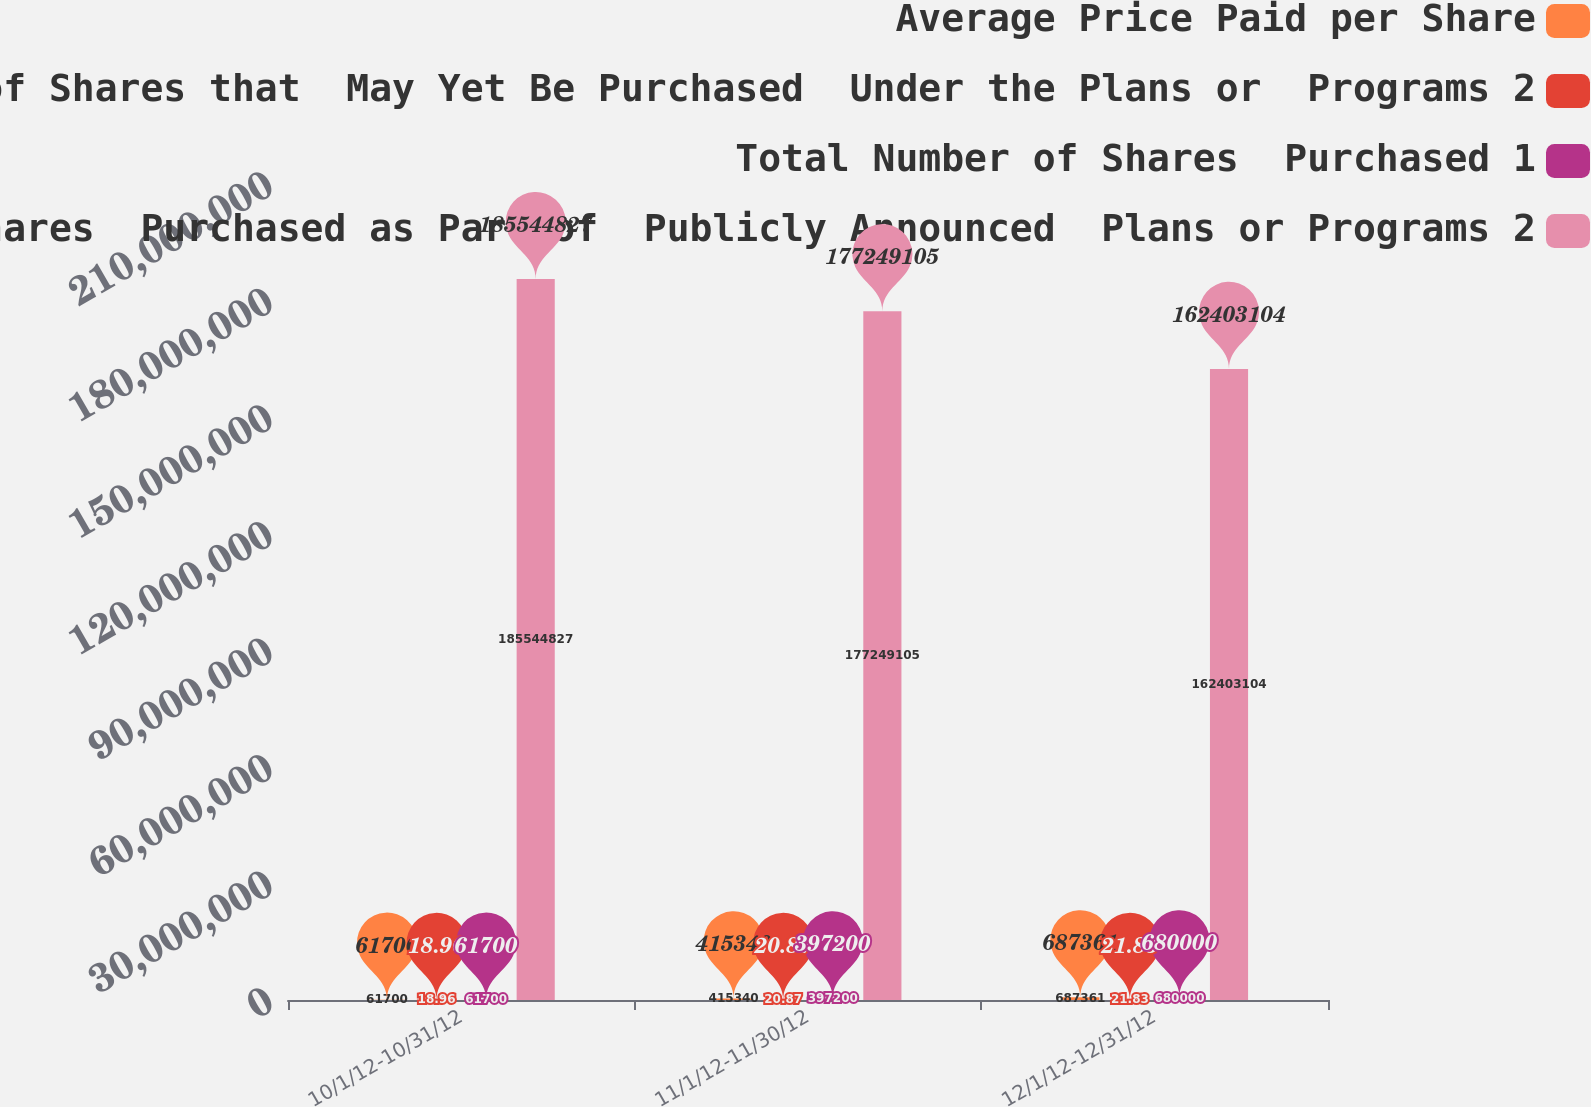Convert chart. <chart><loc_0><loc_0><loc_500><loc_500><stacked_bar_chart><ecel><fcel>10/1/12-10/31/12<fcel>11/1/12-11/30/12<fcel>12/1/12-12/31/12<nl><fcel>Average Price Paid per Share<fcel>61700<fcel>415340<fcel>687361<nl><fcel>Maximum  Approximate Dollar  Value of Shares that  May Yet Be Purchased  Under the Plans or  Programs 2<fcel>18.96<fcel>20.87<fcel>21.83<nl><fcel>Total Number of Shares  Purchased 1<fcel>61700<fcel>397200<fcel>680000<nl><fcel>Total Number of Shares  Purchased as Part of  Publicly Announced  Plans or Programs 2<fcel>1.85545e+08<fcel>1.77249e+08<fcel>1.62403e+08<nl></chart> 